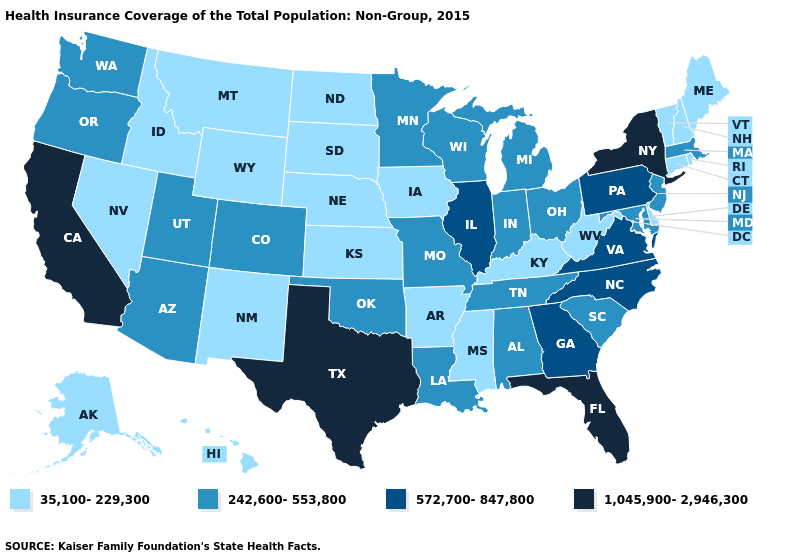What is the value of North Carolina?
Write a very short answer. 572,700-847,800. Does Missouri have the lowest value in the MidWest?
Be succinct. No. What is the lowest value in states that border Delaware?
Short answer required. 242,600-553,800. Name the states that have a value in the range 572,700-847,800?
Quick response, please. Georgia, Illinois, North Carolina, Pennsylvania, Virginia. What is the value of Missouri?
Answer briefly. 242,600-553,800. Name the states that have a value in the range 242,600-553,800?
Give a very brief answer. Alabama, Arizona, Colorado, Indiana, Louisiana, Maryland, Massachusetts, Michigan, Minnesota, Missouri, New Jersey, Ohio, Oklahoma, Oregon, South Carolina, Tennessee, Utah, Washington, Wisconsin. Among the states that border Massachusetts , which have the highest value?
Concise answer only. New York. Name the states that have a value in the range 1,045,900-2,946,300?
Give a very brief answer. California, Florida, New York, Texas. Name the states that have a value in the range 1,045,900-2,946,300?
Concise answer only. California, Florida, New York, Texas. What is the highest value in the South ?
Write a very short answer. 1,045,900-2,946,300. What is the lowest value in states that border Montana?
Keep it brief. 35,100-229,300. Does Virginia have the highest value in the USA?
Give a very brief answer. No. What is the value of Missouri?
Give a very brief answer. 242,600-553,800. What is the value of Iowa?
Answer briefly. 35,100-229,300. Which states hav the highest value in the Northeast?
Write a very short answer. New York. 